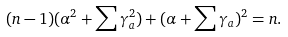<formula> <loc_0><loc_0><loc_500><loc_500>( n - 1 ) ( \alpha ^ { 2 } + \sum \gamma _ { a } ^ { 2 } ) + ( \alpha + \sum \gamma _ { a } ) ^ { 2 } = n .</formula> 